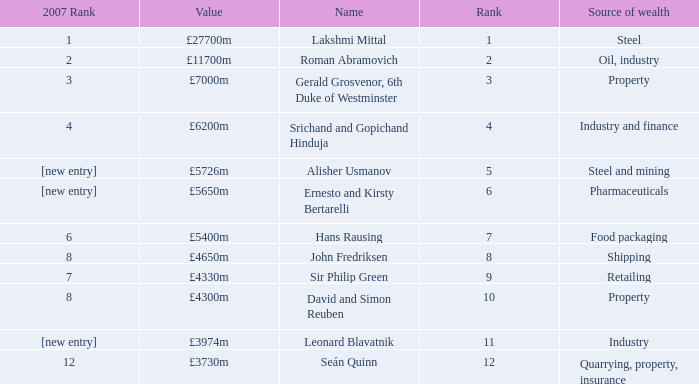What source of wealth has a value of £5726m? Steel and mining. 